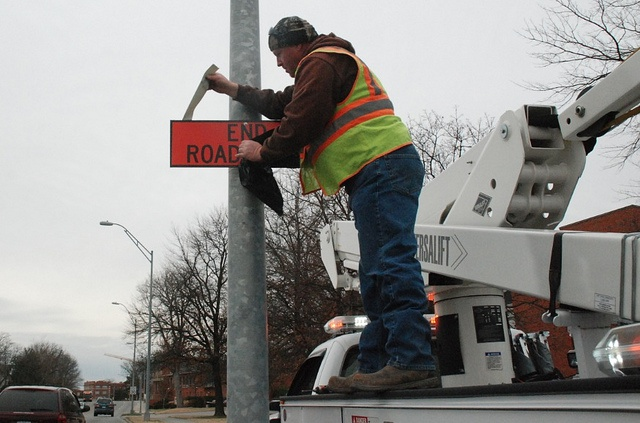Describe the objects in this image and their specific colors. I can see people in lightgray, black, darkgreen, maroon, and gray tones, truck in lightgray, black, gray, and darkgray tones, car in lightgray, black, gray, and darkgray tones, car in lightgray, black, darkgray, and gray tones, and car in lightgray, black, gray, and purple tones in this image. 